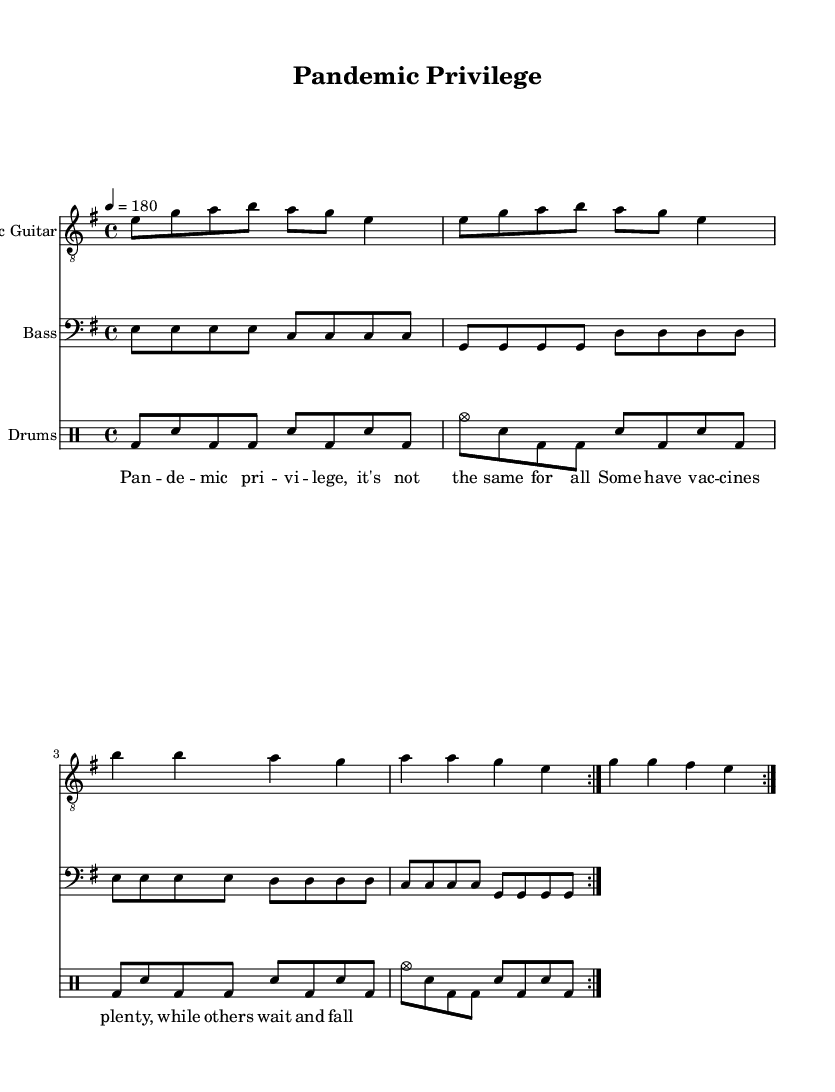What is the key signature of this music? The key signature is E minor, which has one sharp (F#) and corresponds to the notes used in the piece.
Answer: E minor What is the time signature of this piece? The time signature is 4/4, indicating that there are four beats in each measure and the quarter note receives one beat.
Answer: 4/4 What is the tempo marking for the song? The tempo marking is 180 beats per minute, which implies a very fast pace suited for punk music.
Answer: 180 How many measures are repeated in the guitar part? The guitar part indicates a repeat of two measures, denoted by the 'volta' notation in the score.
Answer: 2 What is the general theme of the lyrics? The lyrics address global health inequality, focusing on the disparity in access to vaccines during the pandemic.
Answer: Health inequality What is the instrumentation used in this piece? The instrumentation includes electric guitar, bass guitar, and drums, which are common in punk music for their energetic sound.
Answer: Electric guitar, bass, drums How do the drums contribute to the overall feel of the song? The drums provide a driving rhythm that supports the fast pace, with a steady combination of bass and snare hits characteristic of punk rock.
Answer: Driving rhythm 